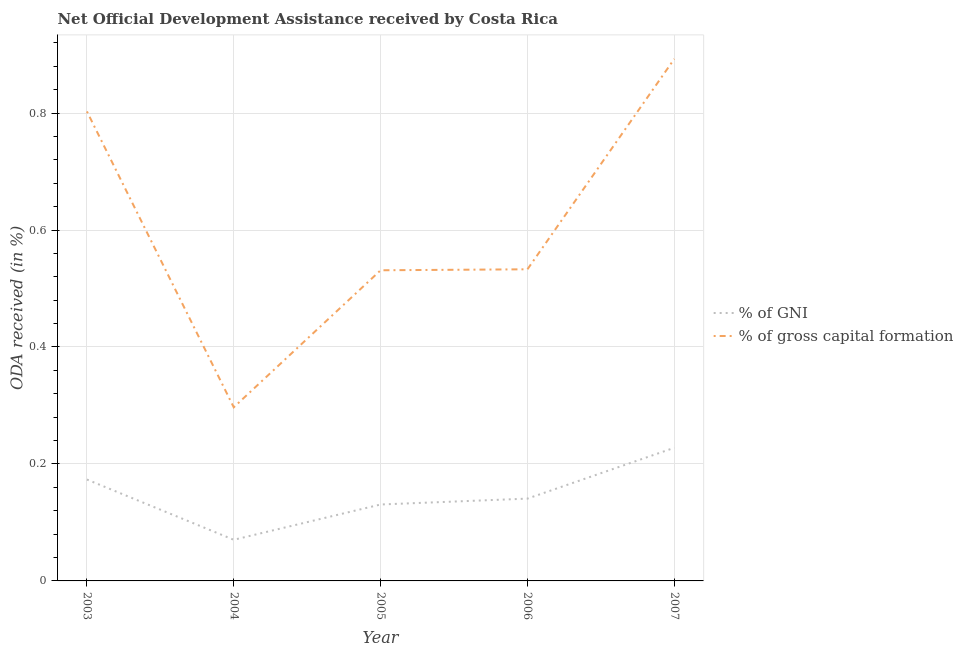How many different coloured lines are there?
Keep it short and to the point. 2. What is the oda received as percentage of gross capital formation in 2006?
Give a very brief answer. 0.53. Across all years, what is the maximum oda received as percentage of gross capital formation?
Your response must be concise. 0.89. Across all years, what is the minimum oda received as percentage of gross capital formation?
Your answer should be very brief. 0.3. In which year was the oda received as percentage of gni maximum?
Your answer should be very brief. 2007. In which year was the oda received as percentage of gni minimum?
Provide a succinct answer. 2004. What is the total oda received as percentage of gni in the graph?
Offer a terse response. 0.74. What is the difference between the oda received as percentage of gross capital formation in 2004 and that in 2005?
Your response must be concise. -0.23. What is the difference between the oda received as percentage of gross capital formation in 2005 and the oda received as percentage of gni in 2003?
Give a very brief answer. 0.36. What is the average oda received as percentage of gni per year?
Your answer should be very brief. 0.15. In the year 2004, what is the difference between the oda received as percentage of gni and oda received as percentage of gross capital formation?
Provide a succinct answer. -0.23. In how many years, is the oda received as percentage of gross capital formation greater than 0.52 %?
Make the answer very short. 4. What is the ratio of the oda received as percentage of gni in 2004 to that in 2005?
Provide a short and direct response. 0.54. Is the oda received as percentage of gni in 2003 less than that in 2005?
Keep it short and to the point. No. Is the difference between the oda received as percentage of gross capital formation in 2004 and 2006 greater than the difference between the oda received as percentage of gni in 2004 and 2006?
Keep it short and to the point. No. What is the difference between the highest and the second highest oda received as percentage of gross capital formation?
Keep it short and to the point. 0.09. What is the difference between the highest and the lowest oda received as percentage of gni?
Keep it short and to the point. 0.16. In how many years, is the oda received as percentage of gni greater than the average oda received as percentage of gni taken over all years?
Offer a very short reply. 2. Does the oda received as percentage of gross capital formation monotonically increase over the years?
Provide a short and direct response. No. How many lines are there?
Your response must be concise. 2. How many years are there in the graph?
Your answer should be compact. 5. Where does the legend appear in the graph?
Give a very brief answer. Center right. How are the legend labels stacked?
Your response must be concise. Vertical. What is the title of the graph?
Your answer should be very brief. Net Official Development Assistance received by Costa Rica. Does "Start a business" appear as one of the legend labels in the graph?
Offer a terse response. No. What is the label or title of the Y-axis?
Your answer should be compact. ODA received (in %). What is the ODA received (in %) of % of GNI in 2003?
Provide a succinct answer. 0.17. What is the ODA received (in %) of % of gross capital formation in 2003?
Give a very brief answer. 0.8. What is the ODA received (in %) in % of GNI in 2004?
Make the answer very short. 0.07. What is the ODA received (in %) of % of gross capital formation in 2004?
Your answer should be very brief. 0.3. What is the ODA received (in %) in % of GNI in 2005?
Provide a short and direct response. 0.13. What is the ODA received (in %) of % of gross capital formation in 2005?
Give a very brief answer. 0.53. What is the ODA received (in %) of % of GNI in 2006?
Your answer should be compact. 0.14. What is the ODA received (in %) in % of gross capital formation in 2006?
Keep it short and to the point. 0.53. What is the ODA received (in %) of % of GNI in 2007?
Your answer should be compact. 0.23. What is the ODA received (in %) of % of gross capital formation in 2007?
Make the answer very short. 0.89. Across all years, what is the maximum ODA received (in %) in % of GNI?
Give a very brief answer. 0.23. Across all years, what is the maximum ODA received (in %) of % of gross capital formation?
Provide a succinct answer. 0.89. Across all years, what is the minimum ODA received (in %) in % of GNI?
Provide a succinct answer. 0.07. Across all years, what is the minimum ODA received (in %) in % of gross capital formation?
Ensure brevity in your answer.  0.3. What is the total ODA received (in %) of % of GNI in the graph?
Your answer should be compact. 0.74. What is the total ODA received (in %) in % of gross capital formation in the graph?
Your answer should be compact. 3.06. What is the difference between the ODA received (in %) of % of GNI in 2003 and that in 2004?
Your response must be concise. 0.1. What is the difference between the ODA received (in %) in % of gross capital formation in 2003 and that in 2004?
Your response must be concise. 0.51. What is the difference between the ODA received (in %) of % of GNI in 2003 and that in 2005?
Your response must be concise. 0.04. What is the difference between the ODA received (in %) in % of gross capital formation in 2003 and that in 2005?
Offer a terse response. 0.27. What is the difference between the ODA received (in %) of % of GNI in 2003 and that in 2006?
Your answer should be very brief. 0.03. What is the difference between the ODA received (in %) in % of gross capital formation in 2003 and that in 2006?
Your answer should be very brief. 0.27. What is the difference between the ODA received (in %) of % of GNI in 2003 and that in 2007?
Your answer should be compact. -0.05. What is the difference between the ODA received (in %) of % of gross capital formation in 2003 and that in 2007?
Provide a succinct answer. -0.09. What is the difference between the ODA received (in %) of % of GNI in 2004 and that in 2005?
Offer a very short reply. -0.06. What is the difference between the ODA received (in %) of % of gross capital formation in 2004 and that in 2005?
Your response must be concise. -0.23. What is the difference between the ODA received (in %) in % of GNI in 2004 and that in 2006?
Provide a succinct answer. -0.07. What is the difference between the ODA received (in %) in % of gross capital formation in 2004 and that in 2006?
Provide a short and direct response. -0.24. What is the difference between the ODA received (in %) in % of GNI in 2004 and that in 2007?
Offer a very short reply. -0.16. What is the difference between the ODA received (in %) in % of gross capital formation in 2004 and that in 2007?
Give a very brief answer. -0.6. What is the difference between the ODA received (in %) in % of GNI in 2005 and that in 2006?
Your answer should be compact. -0.01. What is the difference between the ODA received (in %) in % of gross capital formation in 2005 and that in 2006?
Provide a short and direct response. -0. What is the difference between the ODA received (in %) in % of GNI in 2005 and that in 2007?
Give a very brief answer. -0.1. What is the difference between the ODA received (in %) of % of gross capital formation in 2005 and that in 2007?
Your response must be concise. -0.36. What is the difference between the ODA received (in %) of % of GNI in 2006 and that in 2007?
Provide a succinct answer. -0.09. What is the difference between the ODA received (in %) in % of gross capital formation in 2006 and that in 2007?
Make the answer very short. -0.36. What is the difference between the ODA received (in %) in % of GNI in 2003 and the ODA received (in %) in % of gross capital formation in 2004?
Your answer should be compact. -0.12. What is the difference between the ODA received (in %) of % of GNI in 2003 and the ODA received (in %) of % of gross capital formation in 2005?
Make the answer very short. -0.36. What is the difference between the ODA received (in %) of % of GNI in 2003 and the ODA received (in %) of % of gross capital formation in 2006?
Make the answer very short. -0.36. What is the difference between the ODA received (in %) of % of GNI in 2003 and the ODA received (in %) of % of gross capital formation in 2007?
Make the answer very short. -0.72. What is the difference between the ODA received (in %) in % of GNI in 2004 and the ODA received (in %) in % of gross capital formation in 2005?
Offer a very short reply. -0.46. What is the difference between the ODA received (in %) in % of GNI in 2004 and the ODA received (in %) in % of gross capital formation in 2006?
Offer a very short reply. -0.46. What is the difference between the ODA received (in %) of % of GNI in 2004 and the ODA received (in %) of % of gross capital formation in 2007?
Provide a short and direct response. -0.82. What is the difference between the ODA received (in %) in % of GNI in 2005 and the ODA received (in %) in % of gross capital formation in 2006?
Offer a terse response. -0.4. What is the difference between the ODA received (in %) in % of GNI in 2005 and the ODA received (in %) in % of gross capital formation in 2007?
Your answer should be compact. -0.76. What is the difference between the ODA received (in %) in % of GNI in 2006 and the ODA received (in %) in % of gross capital formation in 2007?
Provide a short and direct response. -0.75. What is the average ODA received (in %) in % of GNI per year?
Ensure brevity in your answer.  0.15. What is the average ODA received (in %) in % of gross capital formation per year?
Keep it short and to the point. 0.61. In the year 2003, what is the difference between the ODA received (in %) of % of GNI and ODA received (in %) of % of gross capital formation?
Provide a succinct answer. -0.63. In the year 2004, what is the difference between the ODA received (in %) of % of GNI and ODA received (in %) of % of gross capital formation?
Offer a terse response. -0.23. In the year 2005, what is the difference between the ODA received (in %) in % of GNI and ODA received (in %) in % of gross capital formation?
Your response must be concise. -0.4. In the year 2006, what is the difference between the ODA received (in %) in % of GNI and ODA received (in %) in % of gross capital formation?
Provide a succinct answer. -0.39. In the year 2007, what is the difference between the ODA received (in %) in % of GNI and ODA received (in %) in % of gross capital formation?
Give a very brief answer. -0.67. What is the ratio of the ODA received (in %) in % of GNI in 2003 to that in 2004?
Your answer should be compact. 2.47. What is the ratio of the ODA received (in %) of % of gross capital formation in 2003 to that in 2004?
Keep it short and to the point. 2.7. What is the ratio of the ODA received (in %) in % of GNI in 2003 to that in 2005?
Your answer should be compact. 1.33. What is the ratio of the ODA received (in %) in % of gross capital formation in 2003 to that in 2005?
Make the answer very short. 1.51. What is the ratio of the ODA received (in %) of % of GNI in 2003 to that in 2006?
Ensure brevity in your answer.  1.23. What is the ratio of the ODA received (in %) of % of gross capital formation in 2003 to that in 2006?
Your response must be concise. 1.51. What is the ratio of the ODA received (in %) in % of GNI in 2003 to that in 2007?
Your response must be concise. 0.76. What is the ratio of the ODA received (in %) of % of gross capital formation in 2003 to that in 2007?
Keep it short and to the point. 0.9. What is the ratio of the ODA received (in %) of % of GNI in 2004 to that in 2005?
Ensure brevity in your answer.  0.54. What is the ratio of the ODA received (in %) of % of gross capital formation in 2004 to that in 2005?
Offer a terse response. 0.56. What is the ratio of the ODA received (in %) of % of GNI in 2004 to that in 2006?
Offer a terse response. 0.5. What is the ratio of the ODA received (in %) of % of gross capital formation in 2004 to that in 2006?
Offer a terse response. 0.56. What is the ratio of the ODA received (in %) in % of GNI in 2004 to that in 2007?
Give a very brief answer. 0.31. What is the ratio of the ODA received (in %) of % of gross capital formation in 2004 to that in 2007?
Offer a very short reply. 0.33. What is the ratio of the ODA received (in %) of % of GNI in 2005 to that in 2007?
Your response must be concise. 0.57. What is the ratio of the ODA received (in %) of % of gross capital formation in 2005 to that in 2007?
Offer a terse response. 0.6. What is the ratio of the ODA received (in %) of % of GNI in 2006 to that in 2007?
Provide a short and direct response. 0.62. What is the ratio of the ODA received (in %) of % of gross capital formation in 2006 to that in 2007?
Your response must be concise. 0.6. What is the difference between the highest and the second highest ODA received (in %) of % of GNI?
Keep it short and to the point. 0.05. What is the difference between the highest and the second highest ODA received (in %) in % of gross capital formation?
Give a very brief answer. 0.09. What is the difference between the highest and the lowest ODA received (in %) in % of GNI?
Ensure brevity in your answer.  0.16. What is the difference between the highest and the lowest ODA received (in %) of % of gross capital formation?
Your response must be concise. 0.6. 